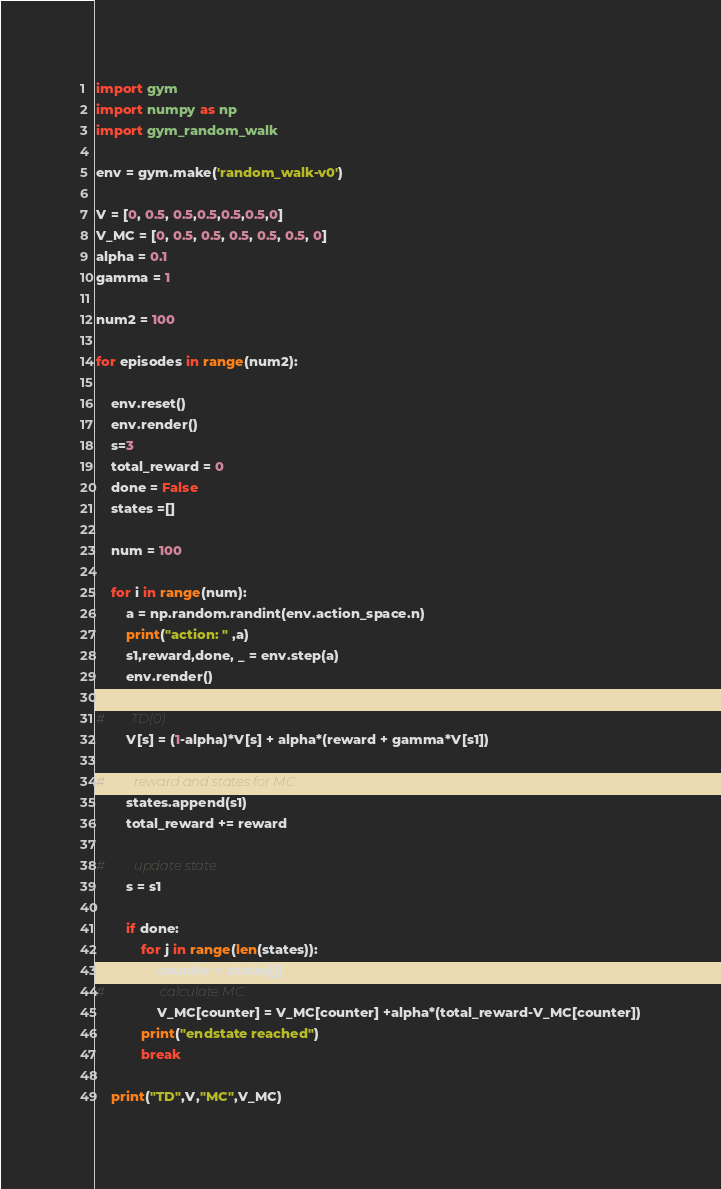<code> <loc_0><loc_0><loc_500><loc_500><_Python_>import gym
import numpy as np
import gym_random_walk

env = gym.make('random_walk-v0')

V = [0, 0.5, 0.5,0.5,0.5,0.5,0]
V_MC = [0, 0.5, 0.5, 0.5, 0.5, 0.5, 0]
alpha = 0.1
gamma = 1

num2 = 100

for episodes in range(num2):

    env.reset()
    env.render()
    s=3
    total_reward = 0
    done = False
    states =[]
    
    num = 100
    
    for i in range(num):
        a = np.random.randint(env.action_space.n)
        print("action: " ,a)
        s1,reward,done, _ = env.step(a)
        env.render()

#        TD(0) 
        V[s] = (1-alpha)*V[s] + alpha*(reward + gamma*V[s1])
        
#         reward and states for MC
        states.append(s1)
        total_reward += reward
        
#         update state
        s = s1
        
        if done:
            for j in range(len(states)):
                counter = states[j]
#                 calculate MC
                V_MC[counter] = V_MC[counter] +alpha*(total_reward-V_MC[counter])
            print("endstate reached")
            break
        
    print("TD",V,"MC",V_MC)
</code> 